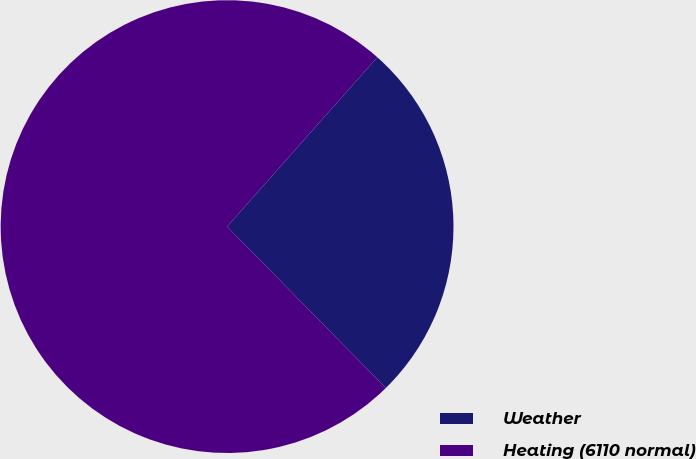Convert chart. <chart><loc_0><loc_0><loc_500><loc_500><pie_chart><fcel>Weather<fcel>Heating (6110 normal)<nl><fcel>26.08%<fcel>73.92%<nl></chart> 